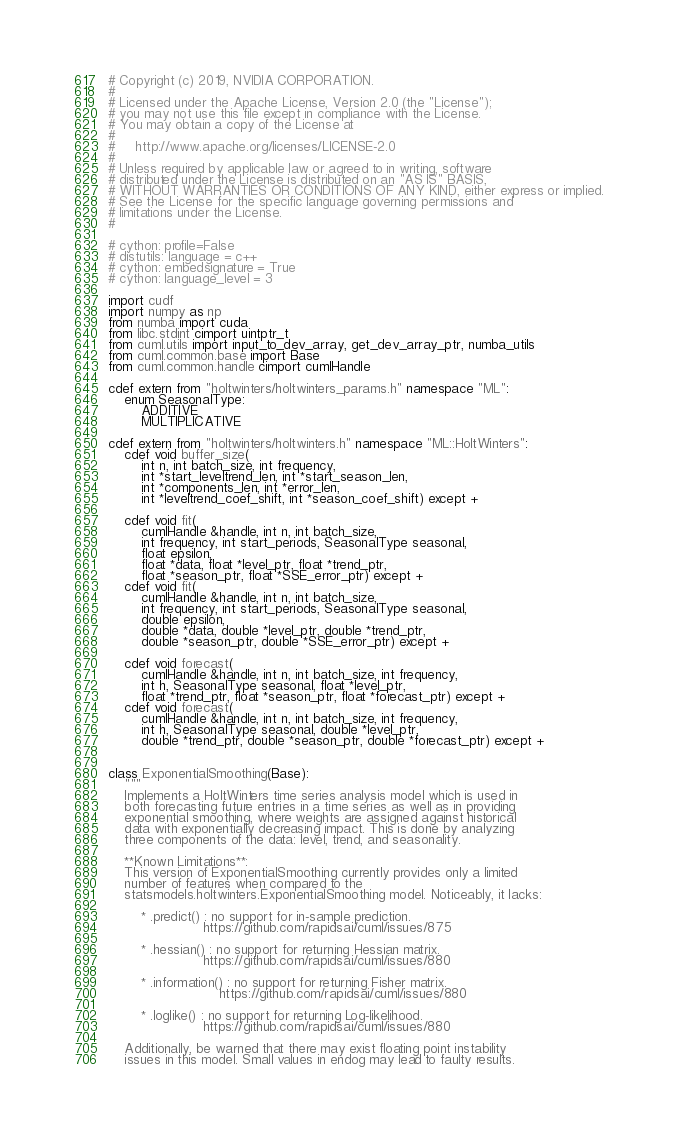Convert code to text. <code><loc_0><loc_0><loc_500><loc_500><_Cython_># Copyright (c) 2019, NVIDIA CORPORATION.
#
# Licensed under the Apache License, Version 2.0 (the "License");
# you may not use this file except in compliance with the License.
# You may obtain a copy of the License at
#
#     http://www.apache.org/licenses/LICENSE-2.0
#
# Unless required by applicable law or agreed to in writing, software
# distributed under the License is distributed on an "AS IS" BASIS,
# WITHOUT WARRANTIES OR CONDITIONS OF ANY KIND, either express or implied.
# See the License for the specific language governing permissions and
# limitations under the License.
#

# cython: profile=False
# distutils: language = c++
# cython: embedsignature = True
# cython: language_level = 3

import cudf
import numpy as np
from numba import cuda
from libc.stdint cimport uintptr_t
from cuml.utils import input_to_dev_array, get_dev_array_ptr, numba_utils
from cuml.common.base import Base
from cuml.common.handle cimport cumlHandle

cdef extern from "holtwinters/holtwinters_params.h" namespace "ML":
    enum SeasonalType:
        ADDITIVE
        MULTIPLICATIVE

cdef extern from "holtwinters/holtwinters.h" namespace "ML::HoltWinters":
    cdef void buffer_size(
        int n, int batch_size, int frequency,
        int *start_leveltrend_len, int *start_season_len,
        int *components_len, int *error_len,
        int *leveltrend_coef_shift, int *season_coef_shift) except +

    cdef void fit(
        cumlHandle &handle, int n, int batch_size,
        int frequency, int start_periods, SeasonalType seasonal,
        float epsilon,
        float *data, float *level_ptr, float *trend_ptr,
        float *season_ptr, float *SSE_error_ptr) except +
    cdef void fit(
        cumlHandle &handle, int n, int batch_size,
        int frequency, int start_periods, SeasonalType seasonal,
        double epsilon,
        double *data, double *level_ptr, double *trend_ptr,
        double *season_ptr, double *SSE_error_ptr) except +

    cdef void forecast(
        cumlHandle &handle, int n, int batch_size, int frequency,
        int h, SeasonalType seasonal, float *level_ptr,
        float *trend_ptr, float *season_ptr, float *forecast_ptr) except +
    cdef void forecast(
        cumlHandle &handle, int n, int batch_size, int frequency,
        int h, SeasonalType seasonal, double *level_ptr,
        double *trend_ptr, double *season_ptr, double *forecast_ptr) except +


class ExponentialSmoothing(Base):
    """
    Implements a HoltWinters time series analysis model which is used in
    both forecasting future entries in a time series as well as in providing
    exponential smoothing, where weights are assigned against historical
    data with exponentially decreasing impact. This is done by analyzing
    three components of the data: level, trend, and seasonality.

    **Known Limitations**:
    This version of ExponentialSmoothing currently provides only a limited
    number of features when compared to the
    statsmodels.holtwinters.ExponentialSmoothing model. Noticeably, it lacks:

        * .predict() : no support for in-sample prediction.
                       https://github.com/rapidsai/cuml/issues/875

        * .hessian() : no support for returning Hessian matrix.
                       https://github.com/rapidsai/cuml/issues/880

        * .information() : no support for returning Fisher matrix.
                           https://github.com/rapidsai/cuml/issues/880

        * .loglike() : no support for returning Log-likelihood.
                       https://github.com/rapidsai/cuml/issues/880

    Additionally, be warned that there may exist floating point instability
    issues in this model. Small values in endog may lead to faulty results.</code> 